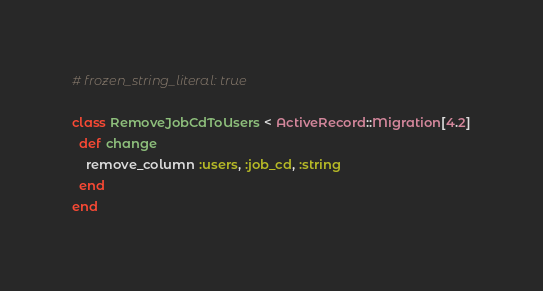Convert code to text. <code><loc_0><loc_0><loc_500><loc_500><_Ruby_># frozen_string_literal: true

class RemoveJobCdToUsers < ActiveRecord::Migration[4.2]
  def change
    remove_column :users, :job_cd, :string
  end
end
</code> 